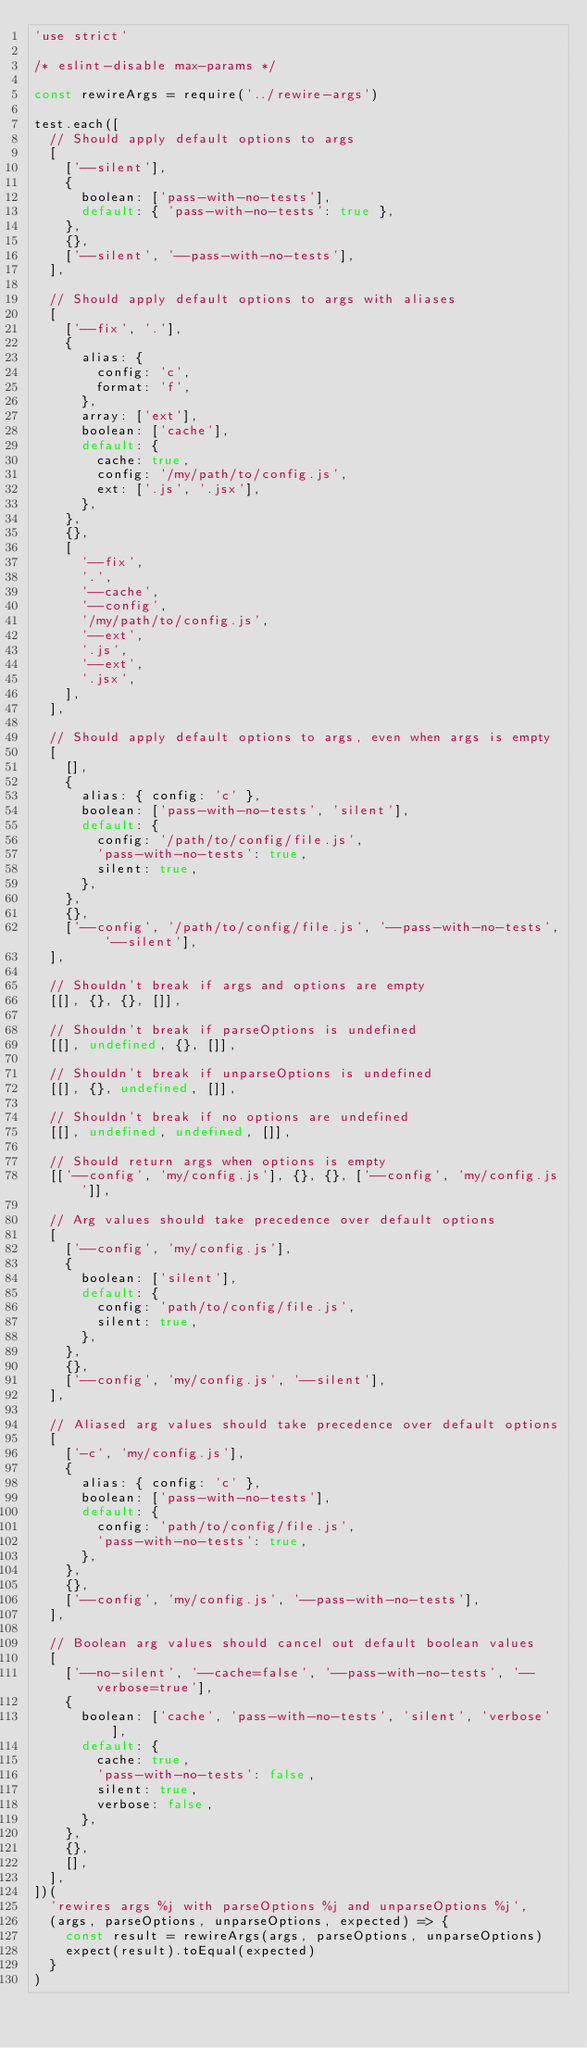<code> <loc_0><loc_0><loc_500><loc_500><_JavaScript_>'use strict'

/* eslint-disable max-params */

const rewireArgs = require('../rewire-args')

test.each([
  // Should apply default options to args
  [
    ['--silent'],
    {
      boolean: ['pass-with-no-tests'],
      default: { 'pass-with-no-tests': true },
    },
    {},
    ['--silent', '--pass-with-no-tests'],
  ],

  // Should apply default options to args with aliases
  [
    ['--fix', '.'],
    {
      alias: {
        config: 'c',
        format: 'f',
      },
      array: ['ext'],
      boolean: ['cache'],
      default: {
        cache: true,
        config: '/my/path/to/config.js',
        ext: ['.js', '.jsx'],
      },
    },
    {},
    [
      '--fix',
      '.',
      '--cache',
      '--config',
      '/my/path/to/config.js',
      '--ext',
      '.js',
      '--ext',
      '.jsx',
    ],
  ],

  // Should apply default options to args, even when args is empty
  [
    [],
    {
      alias: { config: 'c' },
      boolean: ['pass-with-no-tests', 'silent'],
      default: {
        config: '/path/to/config/file.js',
        'pass-with-no-tests': true,
        silent: true,
      },
    },
    {},
    ['--config', '/path/to/config/file.js', '--pass-with-no-tests', '--silent'],
  ],

  // Shouldn't break if args and options are empty
  [[], {}, {}, []],

  // Shouldn't break if parseOptions is undefined
  [[], undefined, {}, []],

  // Shouldn't break if unparseOptions is undefined
  [[], {}, undefined, []],

  // Shouldn't break if no options are undefined
  [[], undefined, undefined, []],

  // Should return args when options is empty
  [['--config', 'my/config.js'], {}, {}, ['--config', 'my/config.js']],

  // Arg values should take precedence over default options
  [
    ['--config', 'my/config.js'],
    {
      boolean: ['silent'],
      default: {
        config: 'path/to/config/file.js',
        silent: true,
      },
    },
    {},
    ['--config', 'my/config.js', '--silent'],
  ],

  // Aliased arg values should take precedence over default options
  [
    ['-c', 'my/config.js'],
    {
      alias: { config: 'c' },
      boolean: ['pass-with-no-tests'],
      default: {
        config: 'path/to/config/file.js',
        'pass-with-no-tests': true,
      },
    },
    {},
    ['--config', 'my/config.js', '--pass-with-no-tests'],
  ],

  // Boolean arg values should cancel out default boolean values
  [
    ['--no-silent', '--cache=false', '--pass-with-no-tests', '--verbose=true'],
    {
      boolean: ['cache', 'pass-with-no-tests', 'silent', 'verbose'],
      default: {
        cache: true,
        'pass-with-no-tests': false,
        silent: true,
        verbose: false,
      },
    },
    {},
    [],
  ],
])(
  'rewires args %j with parseOptions %j and unparseOptions %j',
  (args, parseOptions, unparseOptions, expected) => {
    const result = rewireArgs(args, parseOptions, unparseOptions)
    expect(result).toEqual(expected)
  }
)
</code> 